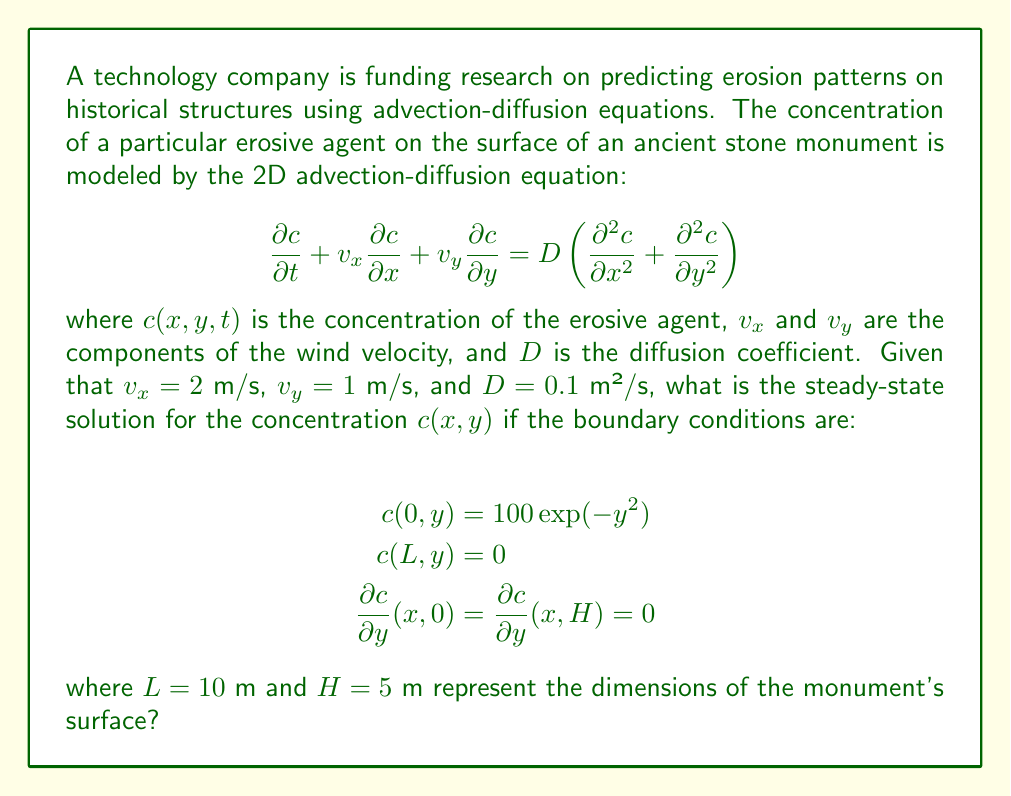Can you solve this math problem? To solve this problem, we need to follow these steps:

1) For the steady-state solution, we set $\frac{\partial c}{\partial t} = 0$. The equation becomes:

   $$v_x \frac{\partial c}{\partial x} + v_y \frac{\partial c}{\partial y} = D \left(\frac{\partial^2 c}{\partial x^2} + \frac{\partial^2 c}{\partial y^2}\right)$$

2) Substituting the given values:

   $$2 \frac{\partial c}{\partial x} + \frac{\partial c}{\partial y} = 0.1 \left(\frac{\partial^2 c}{\partial x^2} + \frac{\partial^2 c}{\partial y^2}\right)$$

3) We can solve this equation using separation of variables. Let $c(x,y) = X(x)Y(y)$. Substituting this into the equation:

   $$2X'Y + XY' = 0.1(X''Y + XY'')$$

4) Dividing by $XY$:

   $$\frac{2X'}{X} + \frac{Y'}{Y} = 0.1\left(\frac{X''}{X} + \frac{Y''}{Y}\right)$$

5) For this to be true for all $x$ and $y$, both sides must equal a constant. Let's call this constant $-k^2$:

   $$\frac{X''}{X} - \frac{20X'}{X} = -k^2$$
   $$\frac{Y''}{Y} - \frac{10Y'}{Y} = k^2 - 0.1k^2 = 0.9k^2$$

6) The solution for $X(x)$ is of the form:

   $$X(x) = A\exp(r_1x) + B\exp(r_2x)$$

   where $r_1$ and $r_2$ are roots of $r^2 - 20r + k^2 = 0$

7) The solution for $Y(y)$ is of the form:

   $$Y(y) = C\exp(sy) + D\exp(-sy)$$

   where $s^2 - 10s - 0.9k^2 = 0$

8) Applying the boundary conditions:

   At $x = 0$: $c(0,y) = 100\exp(-y^2)$, so $Y(y) = 100\exp(-y^2)$
   At $x = L$: $c(L,y) = 0$, so $A\exp(r_1L) + B\exp(r_2L) = 0$
   At $y = 0$ and $y = H$: $Y'(0) = Y'(H) = 0$, which is satisfied by $Y(y) = 100\exp(-y^2)$

9) The final solution is of the form:

   $$c(x,y) = 100\exp(-y^2)(A\exp(r_1x) + B\exp(r_2x))$$

   where $A$ and $B$ are determined by the boundary conditions at $x = 0$ and $x = L$.

10) Solving for $A$ and $B$:

    At $x = 0$: $A + B = 1$
    At $x = L$: $A\exp(r_1L) + B\exp(r_2L) = 0$

    Solving these equations gives:

    $$A = \frac{\exp(r_2L)}{\exp(r_2L) - \exp(r_1L)}$$
    $$B = \frac{-\exp(r_1L)}{\exp(r_2L) - \exp(r_1L)}$$

Thus, the final steady-state solution is:

$$c(x,y) = 100\exp(-y^2)\left(\frac{\exp(r_2L)\exp(r_1x) - \exp(r_1L)\exp(r_2x)}{\exp(r_2L) - \exp(r_1L)}\right)$$

where $r_1$ and $r_2$ are the roots of $r^2 - 20r + k^2 = 0$, and $k$ is determined from $s^2 - 10s - 0.9k^2 = 0$ with $s = 2$ (from the $\exp(-y^2)$ term).
Answer: $$c(x,y) = 100\exp(-y^2)\left(\frac{\exp(r_2L)\exp(r_1x) - \exp(r_1L)\exp(r_2x)}{\exp(r_2L) - \exp(r_1L)}\right)$$

where $r_1$ and $r_2$ are the roots of $r^2 - 20r + k^2 = 0$, and $k$ is determined from $s^2 - 10s - 0.9k^2 = 0$ with $s = 2$. 